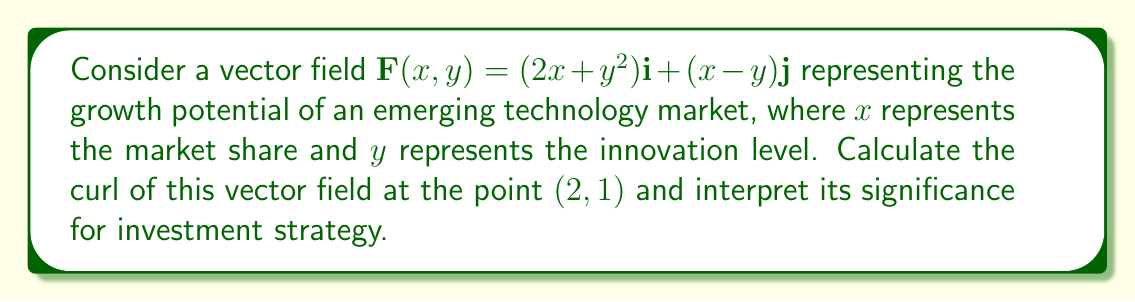Give your solution to this math problem. To solve this problem, we'll follow these steps:

1) The curl of a vector field in 2D is given by:

   $\text{curl } \mathbf{F} = \nabla \times \mathbf{F} = \left(\frac{\partial F_y}{\partial x} - \frac{\partial F_x}{\partial y}\right)\mathbf{k}$

2) For our vector field $\mathbf{F}(x,y) = (2x+y^2)\mathbf{i} + (x-y)\mathbf{j}$:
   
   $F_x = 2x+y^2$
   $F_y = x-y$

3) Calculate the partial derivatives:

   $\frac{\partial F_y}{\partial x} = 1$
   $\frac{\partial F_x}{\partial y} = 2y$

4) Substitute into the curl formula:

   $\text{curl } \mathbf{F} = (1 - 2y)\mathbf{k}$

5) Evaluate at the point $(2,1)$:

   $\text{curl } \mathbf{F}(2,1) = (1 - 2(1))\mathbf{k} = -1\mathbf{k}$

Interpretation: The non-zero curl indicates rotational behavior in the growth potential field. The negative value suggests a clockwise rotation at (2,1). For an investment manager, this implies that at this point in the market (market share = 2, innovation level = 1), there's a tendency for growth to shift from innovation to market share expansion. This could signal a good time to invest in companies focusing on market expansion rather than pure innovation.
Answer: $-1\mathbf{k}$ 